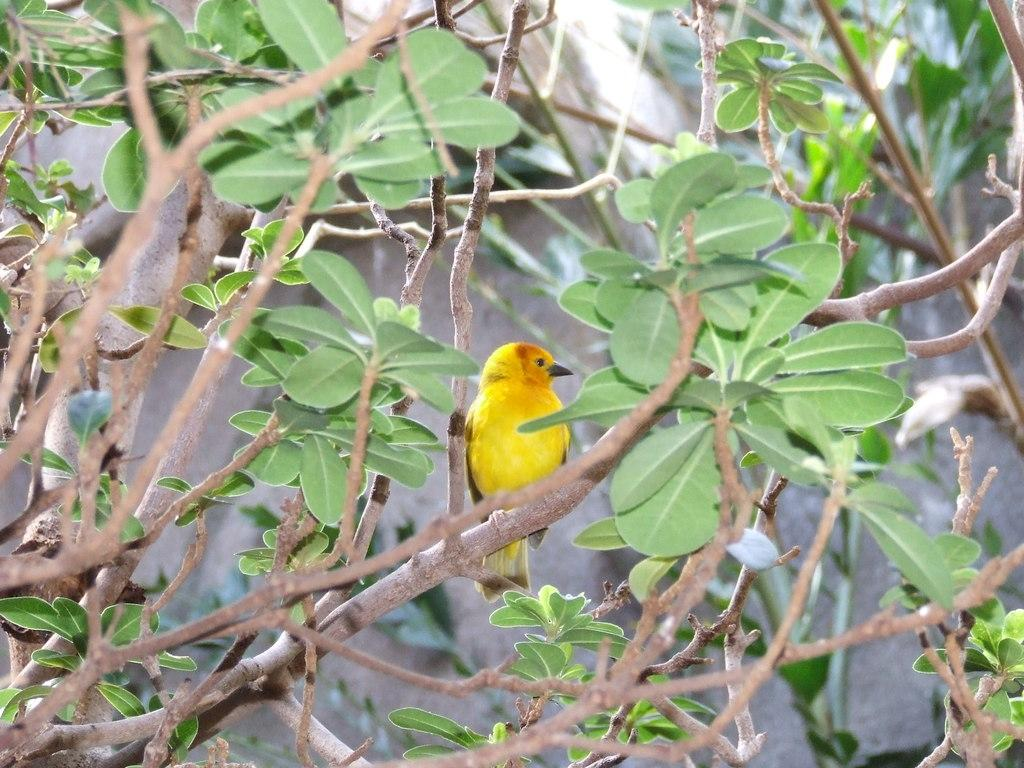What type of bird is in the image? There is a sparrow in the image. Where is the sparrow located in the image? The sparrow is sitting on a tree branch. What can be seen in the image besides the sparrow? There are leaves and trees in the image. What is visible in the background of the image? There is a rock in the background of the image. What type of chess piece is sitting on the tree branch in the image? There are no chess pieces present in the image; it features a sparrow sitting on a tree branch. Can you tell me how many jellyfish are swimming in the background of the image? There are no jellyfish present in the image; it features a rock in the background. 